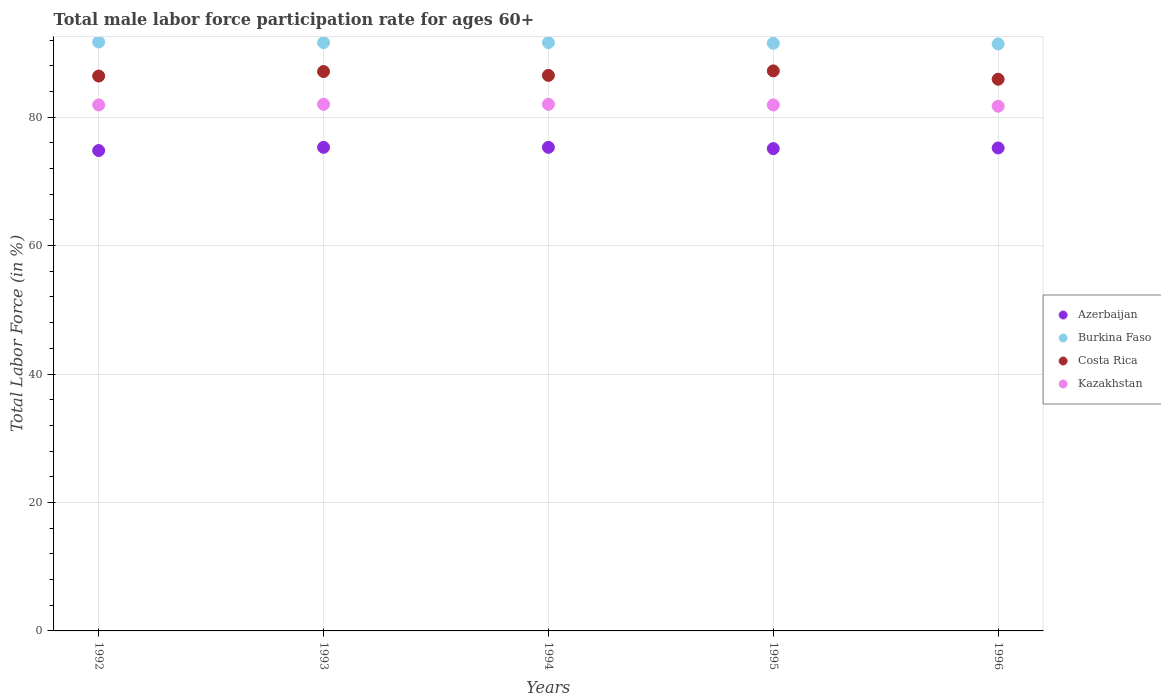Is the number of dotlines equal to the number of legend labels?
Keep it short and to the point. Yes. What is the male labor force participation rate in Azerbaijan in 1992?
Your answer should be compact. 74.8. Across all years, what is the maximum male labor force participation rate in Costa Rica?
Provide a succinct answer. 87.2. Across all years, what is the minimum male labor force participation rate in Kazakhstan?
Provide a short and direct response. 81.7. In which year was the male labor force participation rate in Burkina Faso maximum?
Make the answer very short. 1992. What is the total male labor force participation rate in Burkina Faso in the graph?
Ensure brevity in your answer.  457.8. What is the difference between the male labor force participation rate in Costa Rica in 1995 and that in 1996?
Keep it short and to the point. 1.3. What is the difference between the male labor force participation rate in Azerbaijan in 1994 and the male labor force participation rate in Burkina Faso in 1995?
Give a very brief answer. -16.2. What is the average male labor force participation rate in Azerbaijan per year?
Ensure brevity in your answer.  75.14. In the year 1992, what is the difference between the male labor force participation rate in Costa Rica and male labor force participation rate in Burkina Faso?
Offer a terse response. -5.3. What is the ratio of the male labor force participation rate in Azerbaijan in 1992 to that in 1996?
Offer a very short reply. 0.99. Is the male labor force participation rate in Kazakhstan in 1993 less than that in 1996?
Your answer should be very brief. No. What is the difference between the highest and the second highest male labor force participation rate in Burkina Faso?
Give a very brief answer. 0.1. What is the difference between the highest and the lowest male labor force participation rate in Kazakhstan?
Your response must be concise. 0.3. In how many years, is the male labor force participation rate in Burkina Faso greater than the average male labor force participation rate in Burkina Faso taken over all years?
Ensure brevity in your answer.  3. Is the sum of the male labor force participation rate in Costa Rica in 1994 and 1995 greater than the maximum male labor force participation rate in Kazakhstan across all years?
Provide a succinct answer. Yes. Is it the case that in every year, the sum of the male labor force participation rate in Costa Rica and male labor force participation rate in Azerbaijan  is greater than the male labor force participation rate in Burkina Faso?
Give a very brief answer. Yes. How many years are there in the graph?
Ensure brevity in your answer.  5. Are the values on the major ticks of Y-axis written in scientific E-notation?
Ensure brevity in your answer.  No. Does the graph contain any zero values?
Your answer should be compact. No. Does the graph contain grids?
Keep it short and to the point. Yes. How many legend labels are there?
Your response must be concise. 4. How are the legend labels stacked?
Provide a succinct answer. Vertical. What is the title of the graph?
Your answer should be compact. Total male labor force participation rate for ages 60+. Does "Grenada" appear as one of the legend labels in the graph?
Make the answer very short. No. What is the label or title of the X-axis?
Make the answer very short. Years. What is the Total Labor Force (in %) of Azerbaijan in 1992?
Give a very brief answer. 74.8. What is the Total Labor Force (in %) of Burkina Faso in 1992?
Make the answer very short. 91.7. What is the Total Labor Force (in %) in Costa Rica in 1992?
Your answer should be very brief. 86.4. What is the Total Labor Force (in %) of Kazakhstan in 1992?
Make the answer very short. 81.9. What is the Total Labor Force (in %) of Azerbaijan in 1993?
Provide a succinct answer. 75.3. What is the Total Labor Force (in %) of Burkina Faso in 1993?
Give a very brief answer. 91.6. What is the Total Labor Force (in %) in Costa Rica in 1993?
Provide a short and direct response. 87.1. What is the Total Labor Force (in %) in Kazakhstan in 1993?
Offer a terse response. 82. What is the Total Labor Force (in %) in Azerbaijan in 1994?
Offer a very short reply. 75.3. What is the Total Labor Force (in %) of Burkina Faso in 1994?
Your answer should be compact. 91.6. What is the Total Labor Force (in %) of Costa Rica in 1994?
Provide a succinct answer. 86.5. What is the Total Labor Force (in %) of Kazakhstan in 1994?
Offer a very short reply. 82. What is the Total Labor Force (in %) in Azerbaijan in 1995?
Provide a short and direct response. 75.1. What is the Total Labor Force (in %) in Burkina Faso in 1995?
Provide a short and direct response. 91.5. What is the Total Labor Force (in %) of Costa Rica in 1995?
Give a very brief answer. 87.2. What is the Total Labor Force (in %) in Kazakhstan in 1995?
Ensure brevity in your answer.  81.9. What is the Total Labor Force (in %) of Azerbaijan in 1996?
Make the answer very short. 75.2. What is the Total Labor Force (in %) in Burkina Faso in 1996?
Offer a very short reply. 91.4. What is the Total Labor Force (in %) of Costa Rica in 1996?
Keep it short and to the point. 85.9. What is the Total Labor Force (in %) in Kazakhstan in 1996?
Offer a terse response. 81.7. Across all years, what is the maximum Total Labor Force (in %) in Azerbaijan?
Your answer should be very brief. 75.3. Across all years, what is the maximum Total Labor Force (in %) in Burkina Faso?
Your answer should be compact. 91.7. Across all years, what is the maximum Total Labor Force (in %) of Costa Rica?
Offer a very short reply. 87.2. Across all years, what is the maximum Total Labor Force (in %) in Kazakhstan?
Make the answer very short. 82. Across all years, what is the minimum Total Labor Force (in %) in Azerbaijan?
Make the answer very short. 74.8. Across all years, what is the minimum Total Labor Force (in %) in Burkina Faso?
Make the answer very short. 91.4. Across all years, what is the minimum Total Labor Force (in %) of Costa Rica?
Offer a terse response. 85.9. Across all years, what is the minimum Total Labor Force (in %) of Kazakhstan?
Give a very brief answer. 81.7. What is the total Total Labor Force (in %) of Azerbaijan in the graph?
Your answer should be very brief. 375.7. What is the total Total Labor Force (in %) in Burkina Faso in the graph?
Provide a succinct answer. 457.8. What is the total Total Labor Force (in %) of Costa Rica in the graph?
Offer a terse response. 433.1. What is the total Total Labor Force (in %) of Kazakhstan in the graph?
Make the answer very short. 409.5. What is the difference between the Total Labor Force (in %) in Azerbaijan in 1992 and that in 1993?
Give a very brief answer. -0.5. What is the difference between the Total Labor Force (in %) of Burkina Faso in 1992 and that in 1993?
Offer a very short reply. 0.1. What is the difference between the Total Labor Force (in %) of Costa Rica in 1992 and that in 1993?
Keep it short and to the point. -0.7. What is the difference between the Total Labor Force (in %) in Kazakhstan in 1992 and that in 1993?
Your answer should be very brief. -0.1. What is the difference between the Total Labor Force (in %) of Azerbaijan in 1992 and that in 1994?
Provide a short and direct response. -0.5. What is the difference between the Total Labor Force (in %) in Burkina Faso in 1992 and that in 1994?
Give a very brief answer. 0.1. What is the difference between the Total Labor Force (in %) in Costa Rica in 1992 and that in 1994?
Your answer should be compact. -0.1. What is the difference between the Total Labor Force (in %) in Kazakhstan in 1992 and that in 1994?
Ensure brevity in your answer.  -0.1. What is the difference between the Total Labor Force (in %) in Costa Rica in 1992 and that in 1996?
Provide a short and direct response. 0.5. What is the difference between the Total Labor Force (in %) of Burkina Faso in 1993 and that in 1994?
Ensure brevity in your answer.  0. What is the difference between the Total Labor Force (in %) of Costa Rica in 1993 and that in 1994?
Your answer should be compact. 0.6. What is the difference between the Total Labor Force (in %) in Kazakhstan in 1993 and that in 1994?
Ensure brevity in your answer.  0. What is the difference between the Total Labor Force (in %) of Kazakhstan in 1993 and that in 1995?
Keep it short and to the point. 0.1. What is the difference between the Total Labor Force (in %) of Azerbaijan in 1994 and that in 1995?
Provide a short and direct response. 0.2. What is the difference between the Total Labor Force (in %) in Costa Rica in 1994 and that in 1995?
Your answer should be very brief. -0.7. What is the difference between the Total Labor Force (in %) of Kazakhstan in 1994 and that in 1995?
Your response must be concise. 0.1. What is the difference between the Total Labor Force (in %) in Azerbaijan in 1994 and that in 1996?
Give a very brief answer. 0.1. What is the difference between the Total Labor Force (in %) of Costa Rica in 1994 and that in 1996?
Your answer should be very brief. 0.6. What is the difference between the Total Labor Force (in %) in Kazakhstan in 1994 and that in 1996?
Offer a very short reply. 0.3. What is the difference between the Total Labor Force (in %) in Azerbaijan in 1995 and that in 1996?
Make the answer very short. -0.1. What is the difference between the Total Labor Force (in %) in Kazakhstan in 1995 and that in 1996?
Ensure brevity in your answer.  0.2. What is the difference between the Total Labor Force (in %) of Azerbaijan in 1992 and the Total Labor Force (in %) of Burkina Faso in 1993?
Keep it short and to the point. -16.8. What is the difference between the Total Labor Force (in %) in Azerbaijan in 1992 and the Total Labor Force (in %) in Costa Rica in 1993?
Make the answer very short. -12.3. What is the difference between the Total Labor Force (in %) of Azerbaijan in 1992 and the Total Labor Force (in %) of Kazakhstan in 1993?
Keep it short and to the point. -7.2. What is the difference between the Total Labor Force (in %) in Burkina Faso in 1992 and the Total Labor Force (in %) in Costa Rica in 1993?
Provide a short and direct response. 4.6. What is the difference between the Total Labor Force (in %) in Costa Rica in 1992 and the Total Labor Force (in %) in Kazakhstan in 1993?
Make the answer very short. 4.4. What is the difference between the Total Labor Force (in %) of Azerbaijan in 1992 and the Total Labor Force (in %) of Burkina Faso in 1994?
Give a very brief answer. -16.8. What is the difference between the Total Labor Force (in %) of Azerbaijan in 1992 and the Total Labor Force (in %) of Costa Rica in 1994?
Offer a very short reply. -11.7. What is the difference between the Total Labor Force (in %) of Burkina Faso in 1992 and the Total Labor Force (in %) of Kazakhstan in 1994?
Your answer should be compact. 9.7. What is the difference between the Total Labor Force (in %) in Azerbaijan in 1992 and the Total Labor Force (in %) in Burkina Faso in 1995?
Your answer should be compact. -16.7. What is the difference between the Total Labor Force (in %) in Azerbaijan in 1992 and the Total Labor Force (in %) in Costa Rica in 1995?
Keep it short and to the point. -12.4. What is the difference between the Total Labor Force (in %) of Azerbaijan in 1992 and the Total Labor Force (in %) of Kazakhstan in 1995?
Ensure brevity in your answer.  -7.1. What is the difference between the Total Labor Force (in %) in Burkina Faso in 1992 and the Total Labor Force (in %) in Kazakhstan in 1995?
Your answer should be very brief. 9.8. What is the difference between the Total Labor Force (in %) of Costa Rica in 1992 and the Total Labor Force (in %) of Kazakhstan in 1995?
Your answer should be compact. 4.5. What is the difference between the Total Labor Force (in %) of Azerbaijan in 1992 and the Total Labor Force (in %) of Burkina Faso in 1996?
Your response must be concise. -16.6. What is the difference between the Total Labor Force (in %) of Azerbaijan in 1992 and the Total Labor Force (in %) of Costa Rica in 1996?
Offer a very short reply. -11.1. What is the difference between the Total Labor Force (in %) in Azerbaijan in 1992 and the Total Labor Force (in %) in Kazakhstan in 1996?
Your answer should be very brief. -6.9. What is the difference between the Total Labor Force (in %) of Burkina Faso in 1992 and the Total Labor Force (in %) of Costa Rica in 1996?
Offer a terse response. 5.8. What is the difference between the Total Labor Force (in %) in Azerbaijan in 1993 and the Total Labor Force (in %) in Burkina Faso in 1994?
Your response must be concise. -16.3. What is the difference between the Total Labor Force (in %) in Azerbaijan in 1993 and the Total Labor Force (in %) in Kazakhstan in 1994?
Make the answer very short. -6.7. What is the difference between the Total Labor Force (in %) of Burkina Faso in 1993 and the Total Labor Force (in %) of Costa Rica in 1994?
Give a very brief answer. 5.1. What is the difference between the Total Labor Force (in %) in Burkina Faso in 1993 and the Total Labor Force (in %) in Kazakhstan in 1994?
Keep it short and to the point. 9.6. What is the difference between the Total Labor Force (in %) of Azerbaijan in 1993 and the Total Labor Force (in %) of Burkina Faso in 1995?
Offer a very short reply. -16.2. What is the difference between the Total Labor Force (in %) in Azerbaijan in 1993 and the Total Labor Force (in %) in Burkina Faso in 1996?
Provide a short and direct response. -16.1. What is the difference between the Total Labor Force (in %) in Azerbaijan in 1993 and the Total Labor Force (in %) in Costa Rica in 1996?
Offer a terse response. -10.6. What is the difference between the Total Labor Force (in %) of Burkina Faso in 1993 and the Total Labor Force (in %) of Costa Rica in 1996?
Give a very brief answer. 5.7. What is the difference between the Total Labor Force (in %) in Costa Rica in 1993 and the Total Labor Force (in %) in Kazakhstan in 1996?
Make the answer very short. 5.4. What is the difference between the Total Labor Force (in %) of Azerbaijan in 1994 and the Total Labor Force (in %) of Burkina Faso in 1995?
Offer a terse response. -16.2. What is the difference between the Total Labor Force (in %) in Azerbaijan in 1994 and the Total Labor Force (in %) in Costa Rica in 1995?
Provide a short and direct response. -11.9. What is the difference between the Total Labor Force (in %) of Azerbaijan in 1994 and the Total Labor Force (in %) of Kazakhstan in 1995?
Offer a terse response. -6.6. What is the difference between the Total Labor Force (in %) in Costa Rica in 1994 and the Total Labor Force (in %) in Kazakhstan in 1995?
Make the answer very short. 4.6. What is the difference between the Total Labor Force (in %) of Azerbaijan in 1994 and the Total Labor Force (in %) of Burkina Faso in 1996?
Keep it short and to the point. -16.1. What is the difference between the Total Labor Force (in %) of Burkina Faso in 1994 and the Total Labor Force (in %) of Costa Rica in 1996?
Your response must be concise. 5.7. What is the difference between the Total Labor Force (in %) of Costa Rica in 1994 and the Total Labor Force (in %) of Kazakhstan in 1996?
Make the answer very short. 4.8. What is the difference between the Total Labor Force (in %) in Azerbaijan in 1995 and the Total Labor Force (in %) in Burkina Faso in 1996?
Provide a succinct answer. -16.3. What is the difference between the Total Labor Force (in %) of Costa Rica in 1995 and the Total Labor Force (in %) of Kazakhstan in 1996?
Give a very brief answer. 5.5. What is the average Total Labor Force (in %) in Azerbaijan per year?
Your answer should be very brief. 75.14. What is the average Total Labor Force (in %) of Burkina Faso per year?
Provide a short and direct response. 91.56. What is the average Total Labor Force (in %) of Costa Rica per year?
Provide a succinct answer. 86.62. What is the average Total Labor Force (in %) of Kazakhstan per year?
Your response must be concise. 81.9. In the year 1992, what is the difference between the Total Labor Force (in %) of Azerbaijan and Total Labor Force (in %) of Burkina Faso?
Your answer should be very brief. -16.9. In the year 1992, what is the difference between the Total Labor Force (in %) of Costa Rica and Total Labor Force (in %) of Kazakhstan?
Your response must be concise. 4.5. In the year 1993, what is the difference between the Total Labor Force (in %) in Azerbaijan and Total Labor Force (in %) in Burkina Faso?
Provide a short and direct response. -16.3. In the year 1993, what is the difference between the Total Labor Force (in %) of Burkina Faso and Total Labor Force (in %) of Costa Rica?
Your answer should be compact. 4.5. In the year 1993, what is the difference between the Total Labor Force (in %) of Burkina Faso and Total Labor Force (in %) of Kazakhstan?
Provide a succinct answer. 9.6. In the year 1993, what is the difference between the Total Labor Force (in %) of Costa Rica and Total Labor Force (in %) of Kazakhstan?
Make the answer very short. 5.1. In the year 1994, what is the difference between the Total Labor Force (in %) in Azerbaijan and Total Labor Force (in %) in Burkina Faso?
Provide a succinct answer. -16.3. In the year 1994, what is the difference between the Total Labor Force (in %) of Azerbaijan and Total Labor Force (in %) of Kazakhstan?
Provide a short and direct response. -6.7. In the year 1994, what is the difference between the Total Labor Force (in %) of Burkina Faso and Total Labor Force (in %) of Costa Rica?
Give a very brief answer. 5.1. In the year 1995, what is the difference between the Total Labor Force (in %) in Azerbaijan and Total Labor Force (in %) in Burkina Faso?
Make the answer very short. -16.4. In the year 1995, what is the difference between the Total Labor Force (in %) in Azerbaijan and Total Labor Force (in %) in Costa Rica?
Offer a terse response. -12.1. In the year 1995, what is the difference between the Total Labor Force (in %) in Azerbaijan and Total Labor Force (in %) in Kazakhstan?
Make the answer very short. -6.8. In the year 1995, what is the difference between the Total Labor Force (in %) in Burkina Faso and Total Labor Force (in %) in Costa Rica?
Your answer should be compact. 4.3. In the year 1996, what is the difference between the Total Labor Force (in %) in Azerbaijan and Total Labor Force (in %) in Burkina Faso?
Your response must be concise. -16.2. In the year 1996, what is the difference between the Total Labor Force (in %) of Azerbaijan and Total Labor Force (in %) of Kazakhstan?
Your answer should be very brief. -6.5. In the year 1996, what is the difference between the Total Labor Force (in %) of Burkina Faso and Total Labor Force (in %) of Costa Rica?
Provide a succinct answer. 5.5. What is the ratio of the Total Labor Force (in %) of Azerbaijan in 1992 to that in 1993?
Offer a very short reply. 0.99. What is the ratio of the Total Labor Force (in %) of Costa Rica in 1992 to that in 1993?
Your response must be concise. 0.99. What is the ratio of the Total Labor Force (in %) of Kazakhstan in 1992 to that in 1993?
Make the answer very short. 1. What is the ratio of the Total Labor Force (in %) of Burkina Faso in 1992 to that in 1994?
Offer a terse response. 1. What is the ratio of the Total Labor Force (in %) in Costa Rica in 1992 to that in 1994?
Give a very brief answer. 1. What is the ratio of the Total Labor Force (in %) of Burkina Faso in 1992 to that in 1995?
Offer a terse response. 1. What is the ratio of the Total Labor Force (in %) of Kazakhstan in 1992 to that in 1995?
Provide a short and direct response. 1. What is the ratio of the Total Labor Force (in %) of Burkina Faso in 1992 to that in 1996?
Make the answer very short. 1. What is the ratio of the Total Labor Force (in %) of Azerbaijan in 1993 to that in 1994?
Your response must be concise. 1. What is the ratio of the Total Labor Force (in %) in Azerbaijan in 1993 to that in 1995?
Give a very brief answer. 1. What is the ratio of the Total Labor Force (in %) of Kazakhstan in 1993 to that in 1995?
Offer a very short reply. 1. What is the ratio of the Total Labor Force (in %) in Burkina Faso in 1993 to that in 1996?
Provide a succinct answer. 1. What is the ratio of the Total Labor Force (in %) of Kazakhstan in 1993 to that in 1996?
Offer a very short reply. 1. What is the ratio of the Total Labor Force (in %) of Azerbaijan in 1994 to that in 1995?
Keep it short and to the point. 1. What is the ratio of the Total Labor Force (in %) in Costa Rica in 1994 to that in 1995?
Provide a succinct answer. 0.99. What is the ratio of the Total Labor Force (in %) of Kazakhstan in 1994 to that in 1995?
Offer a very short reply. 1. What is the ratio of the Total Labor Force (in %) of Azerbaijan in 1994 to that in 1996?
Offer a terse response. 1. What is the ratio of the Total Labor Force (in %) in Azerbaijan in 1995 to that in 1996?
Provide a short and direct response. 1. What is the ratio of the Total Labor Force (in %) in Costa Rica in 1995 to that in 1996?
Offer a terse response. 1.02. What is the ratio of the Total Labor Force (in %) of Kazakhstan in 1995 to that in 1996?
Your answer should be compact. 1. What is the difference between the highest and the second highest Total Labor Force (in %) in Costa Rica?
Provide a short and direct response. 0.1. What is the difference between the highest and the second highest Total Labor Force (in %) in Kazakhstan?
Provide a short and direct response. 0. What is the difference between the highest and the lowest Total Labor Force (in %) of Kazakhstan?
Ensure brevity in your answer.  0.3. 